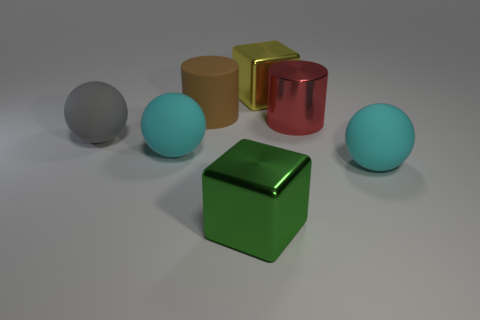Subtract all large cyan rubber spheres. How many spheres are left? 1 Subtract all gray spheres. How many spheres are left? 2 Subtract all spheres. How many objects are left? 4 Subtract 2 cylinders. How many cylinders are left? 0 Add 3 cyan rubber balls. How many objects exist? 10 Subtract all gray balls. How many green blocks are left? 1 Subtract all cyan metal cubes. Subtract all cyan things. How many objects are left? 5 Add 2 metallic cylinders. How many metallic cylinders are left? 3 Add 1 large cyan metallic things. How many large cyan metallic things exist? 1 Subtract 0 purple blocks. How many objects are left? 7 